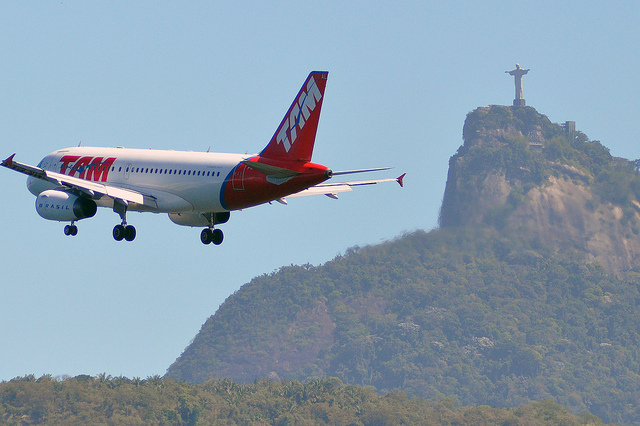What is the color scheme of the airplane? The airplane prominently features a red and white color scheme. The body of the plane is primarily white, with red detailing, including the tail fin and parts of the engine. The 'TAM' logo is displayed in bold red letters, creating a striking contrast against the white fuselage. How does the position of the airplane in the image affect the composition? The airplane's position in the foreground, combined with the Christ the Redeemer statue in the background, creates a layered composition that emphasizes depth. The contrasting scales of the two elements draw the viewer's eye from the foreground airplane to the distant, elevated statue. The dynamic angle of the airplane adds a sense of motion and direction to the scene, enhancing the overall photographic appeal. Imagine an alternate reality where the statue was something other than Christ the Redeemer. Describe what it could be and its significance. In an alternate reality, the hilltop might host a colossal statue of a tropical bird, such as a toucan, symbolizing the rich biodiversity and natural beauty of Brazil's rainforests. This alternate statue would become a beacon of environmental awareness and conservation, drawing attention to the importance of preserving Brazil's diverse ecosystems. Tourists would flock to this symbolic representation of Brazil's natural heritage, reflecting a national pride rooted in ecological sustainability and awareness. What role does the statue play in this image in terms of cultural representation? The Christ the Redeemer statue in this image serves as an enduring symbol of the cultural and spiritual identity of Rio de Janeiro and Brazil at large. It represents a fusion of religious devotion, cultural pride, and national identity. The statue's prominent position in the photograph underscores its significance as a landmark that unifies and inspires both locals and visitors, embodying a universal message of peace and welcome. 